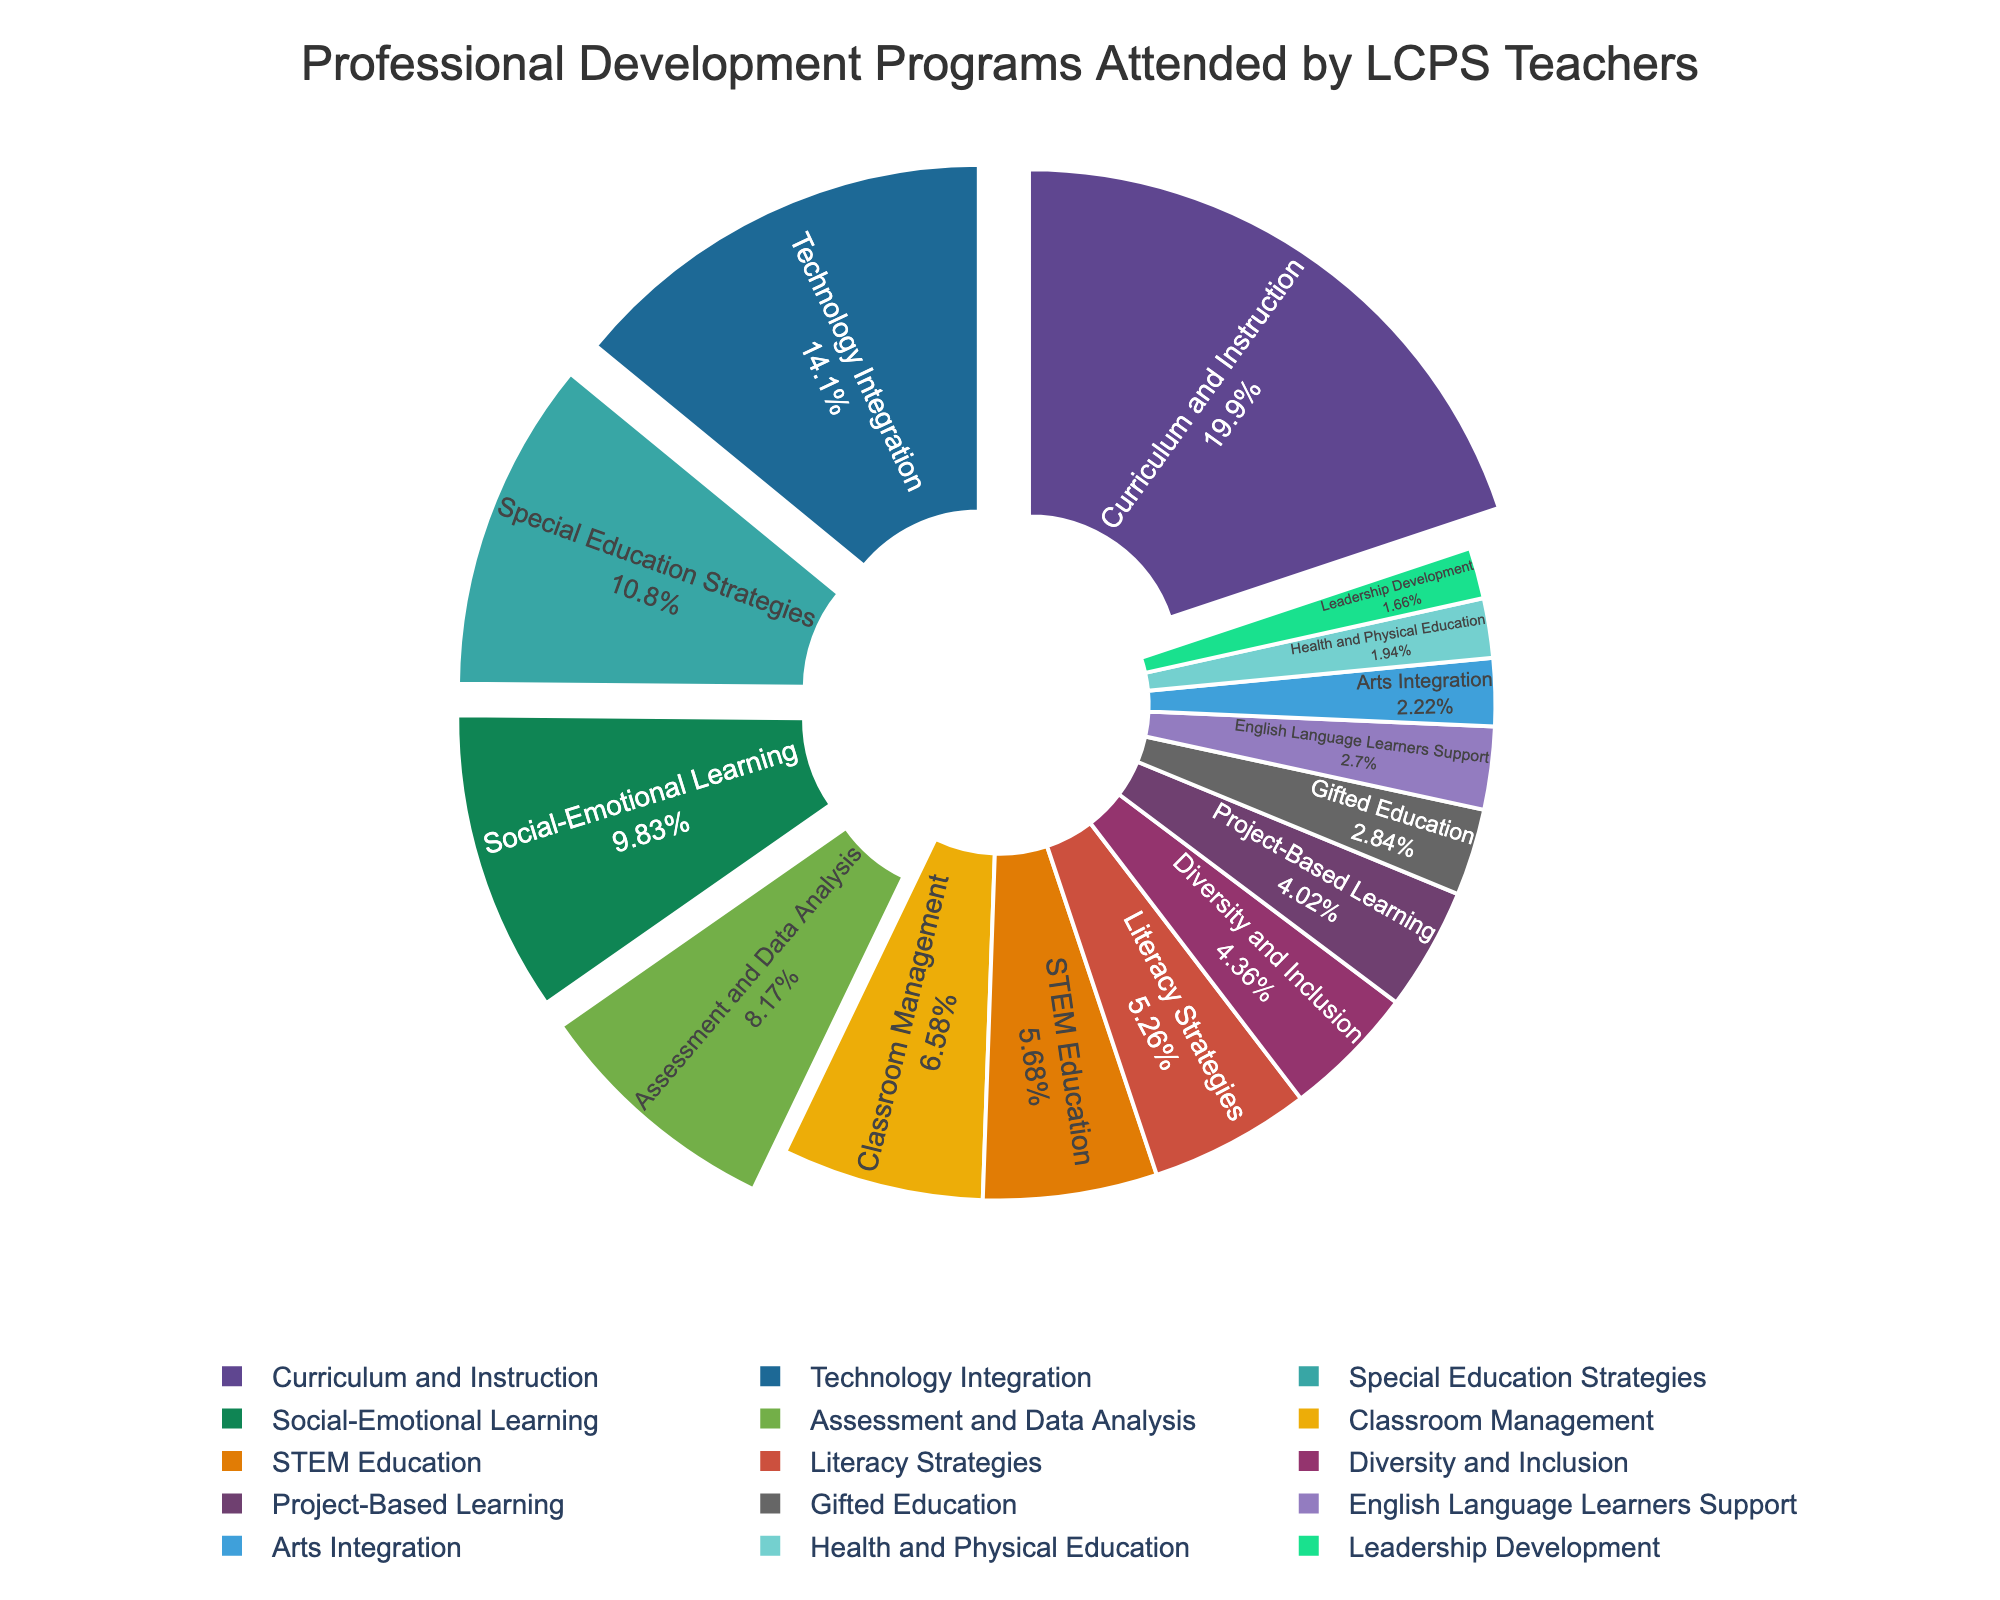What's the most attended professional development program by LCPS teachers? The pie chart clearly shows which program has the largest segment, representing the highest number of teachers.
Answer: Curriculum and Instruction Which program has a larger percentage of attendees: Technology Integration or Special Education Strategies? By comparing the sizes of the segments labeled "Technology Integration" and "Special Education Strategies," it is evident which one is larger.
Answer: Technology Integration How many teachers attended Social-Emotional Learning and Assessment and Data Analysis combined? Look at the number of teachers for both programs and add them together: 142 (Social-Emotional Learning) + 118 (Assessment and Data Analysis).
Answer: 260 Is the number of teachers who attended Leadership Development closer to the number for Arts Integration, or for Health and Physical Education? Compare the number of teachers for Leadership Development (24) to Arts Integration (32) and Health and Physical Education (28). Leadership Development is closer to Health and Physical Education.
Answer: Health and Physical Education What is the difference in the number of teachers attending Project-Based Learning and Literacy Strategies? Subtract the number of teachers for Literacy Strategies (76) from the number for Project-Based Learning (58).
Answer: 18 Which program has the smallest number of attendees? The segment representing the smallest portion of the pie chart indicates the program with the least number of attendees.
Answer: Leadership Development Are there more teachers attending Diversity and Inclusion or Gifted Education programs? Compare the number of teachers attending Diversity and Inclusion (63) with those attending Gifted Education (41).
Answer: Diversity and Inclusion If you combine the number of teachers attending STEM Education, Literacy Strategies, and Diversity and Inclusion, how many attend in total? Add the number of teachers for each program: 82 (STEM Education) + 76 (Literacy Strategies) + 63 (Diversity and Inclusion).
Answer: 221 Which three professional development programs have the highest attendance? Identify the three largest segments on the pie chart and list their corresponding programs.
Answer: Curriculum and Instruction, Technology Integration, Special Education Strategies What percentage of teachers attended Classroom Management? Look at the pie chart segment labeled "Classroom Management" and read off the indicated percentage.
Answer: 8% 